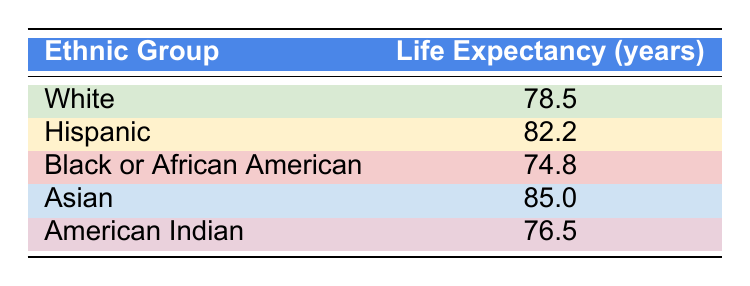What is the life expectancy for the Asian ethnic group? The table directly states the life expectancy for the Asian ethnic group as 85.0 years.
Answer: 85.0 Which ethnic group has the lowest life expectancy in Ector County? Examining the life expectancy values in the table, the Black or African American ethnic group has the lowest life expectancy at 74.8 years.
Answer: Black or African American Calculate the difference in life expectancy between Hispanic and White ethnic groups. The life expectancy for Hispanics is 82.2 years and for Whites is 78.5 years. The difference is calculated as 82.2 - 78.5 = 3.7 years.
Answer: 3.7 Is the life expectancy of the American Indian population higher than that of the Black or African American population? The life expectancy for American Indians is 76.5 years, while for Black or African Americans, it is 74.8 years. Since 76.5 is greater than 74.8, the statement is true.
Answer: Yes What is the average life expectancy of the Hispanic and Asian ethnic groups combined? The life expectancy for Hispanics is 82.2 years and for Asians is 85.0 years. To find the average, we sum these values: 82.2 + 85.0 = 167.2. There are 2 groups, so the average is 167.2 / 2 = 83.6 years.
Answer: 83.6 